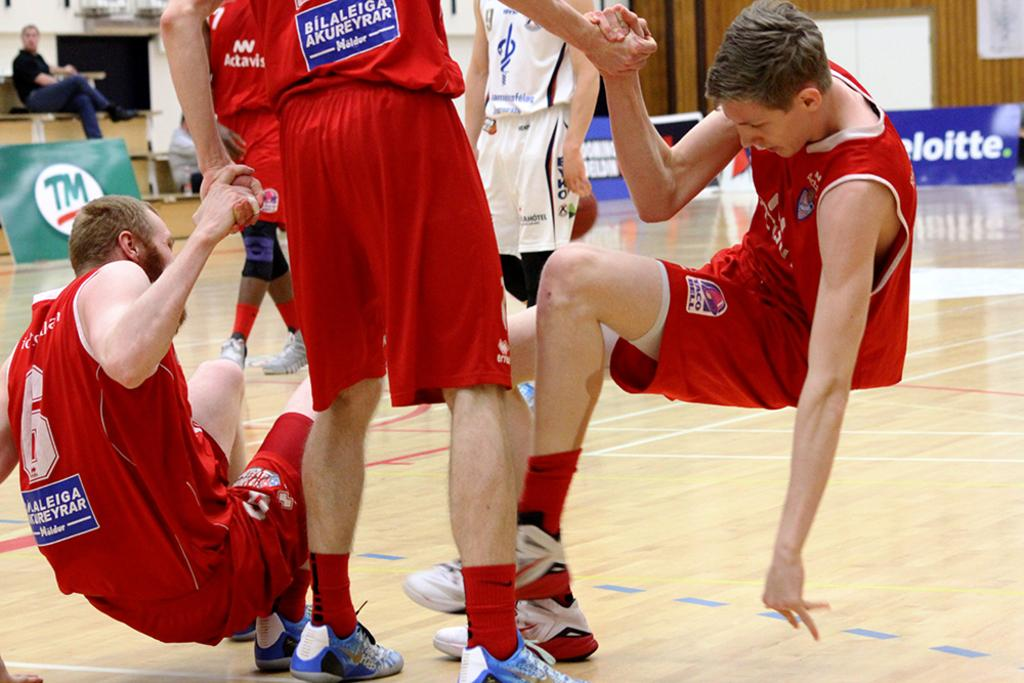<image>
Render a clear and concise summary of the photo. a player that is wearing the number 6 on their jersey 